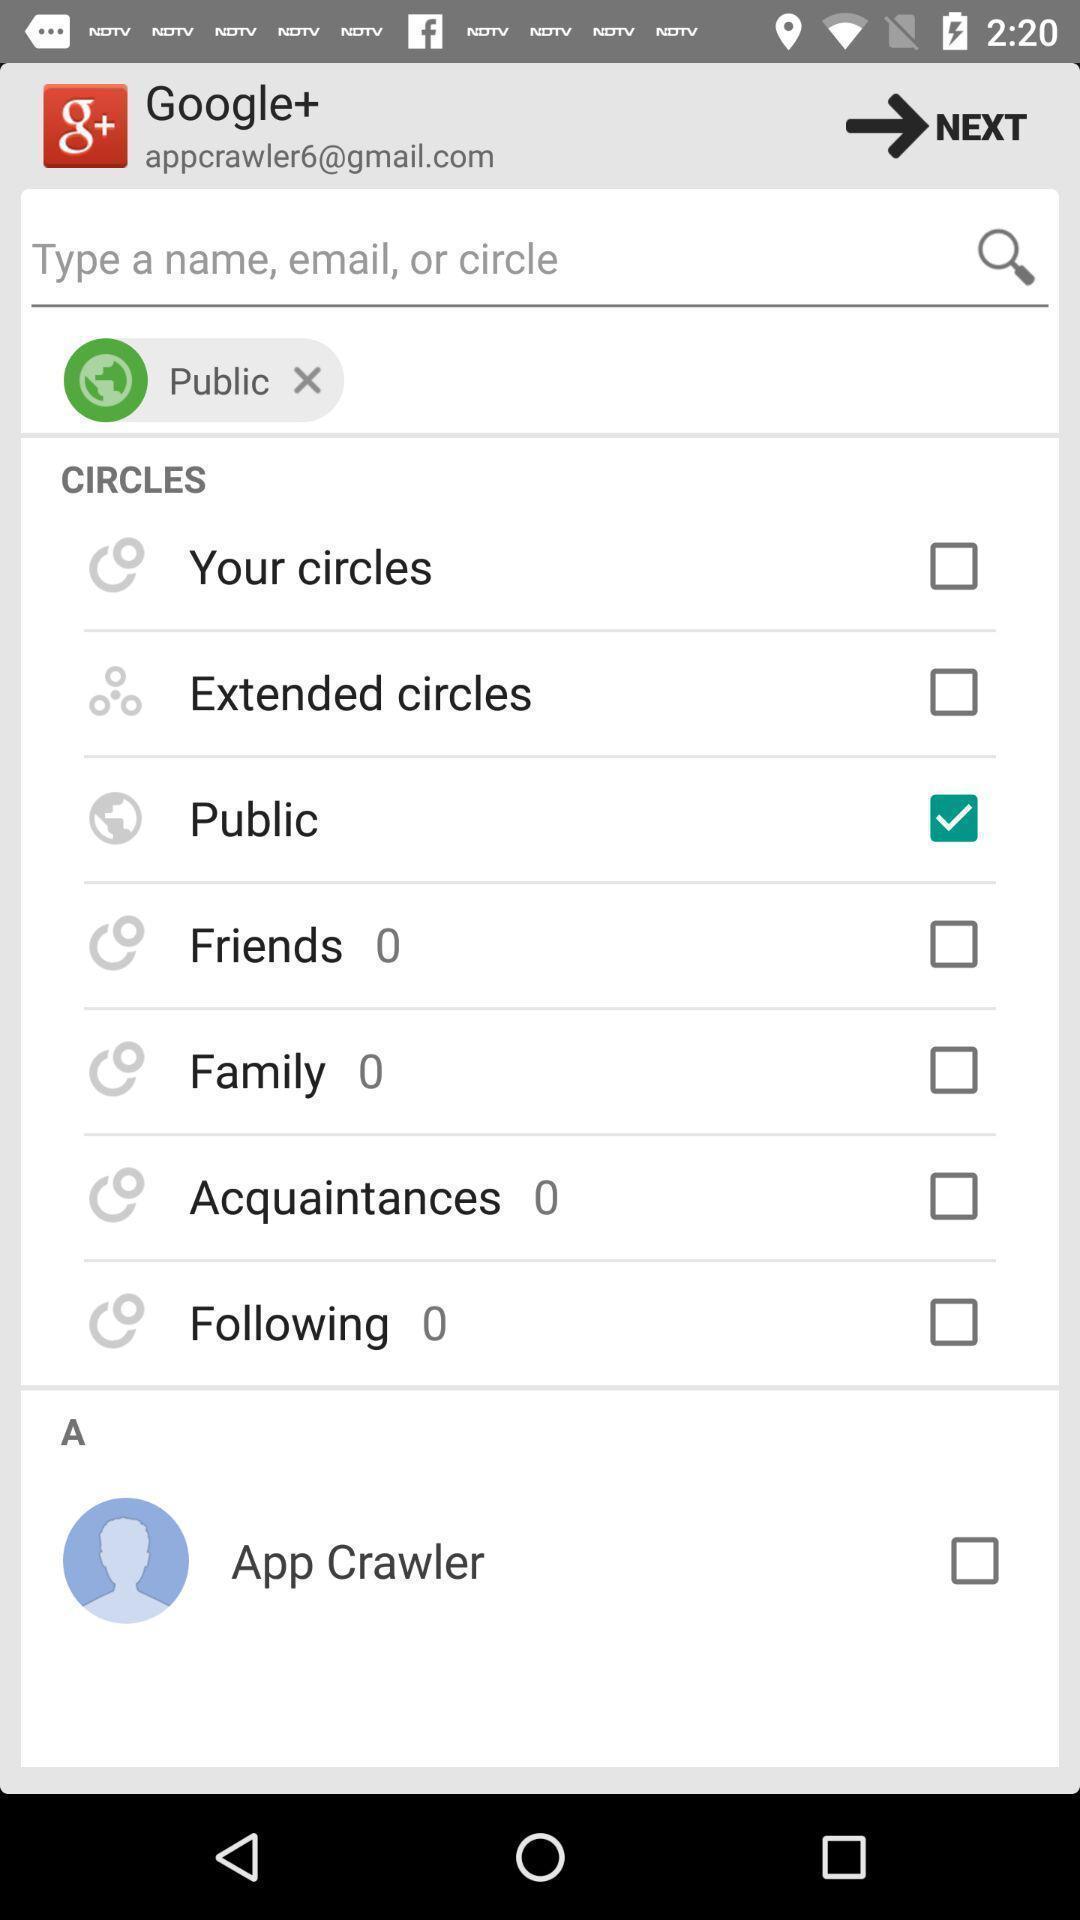Summarize the information in this screenshot. Screen shows an easy community app. 